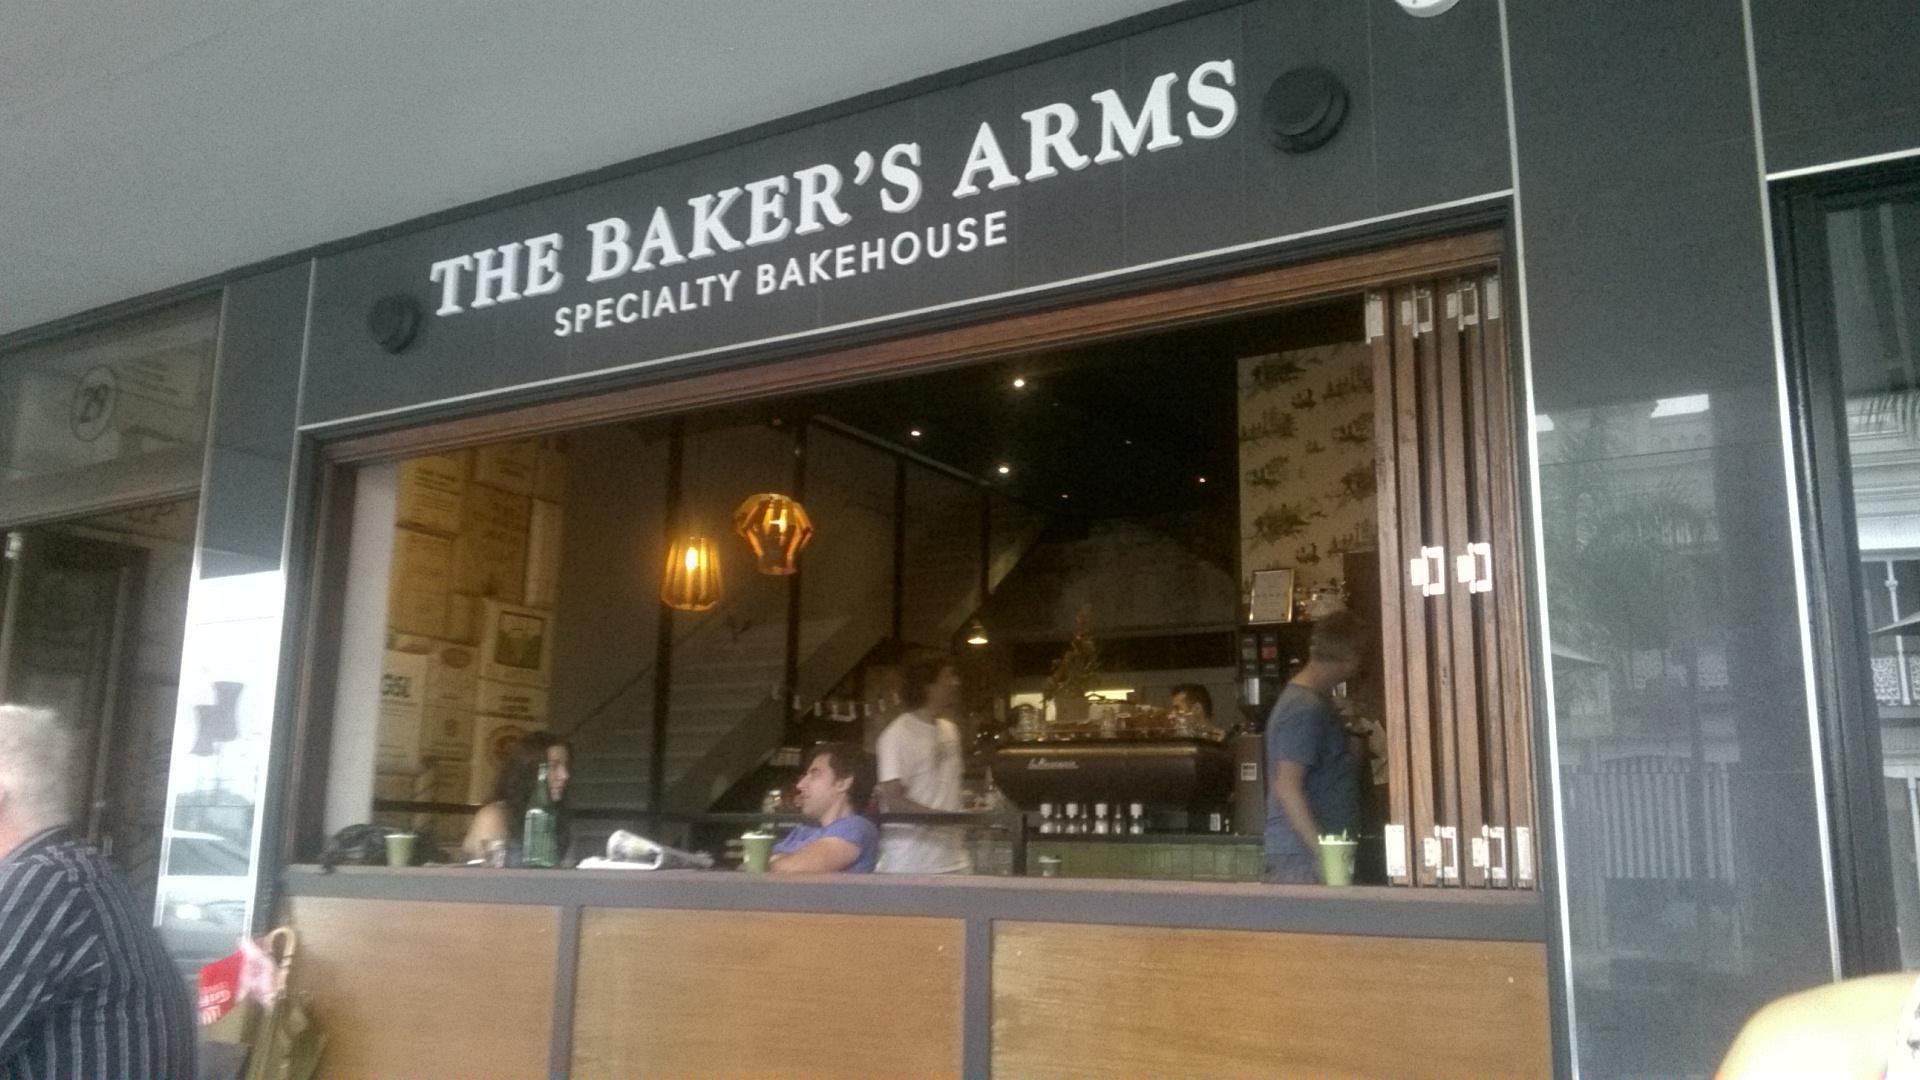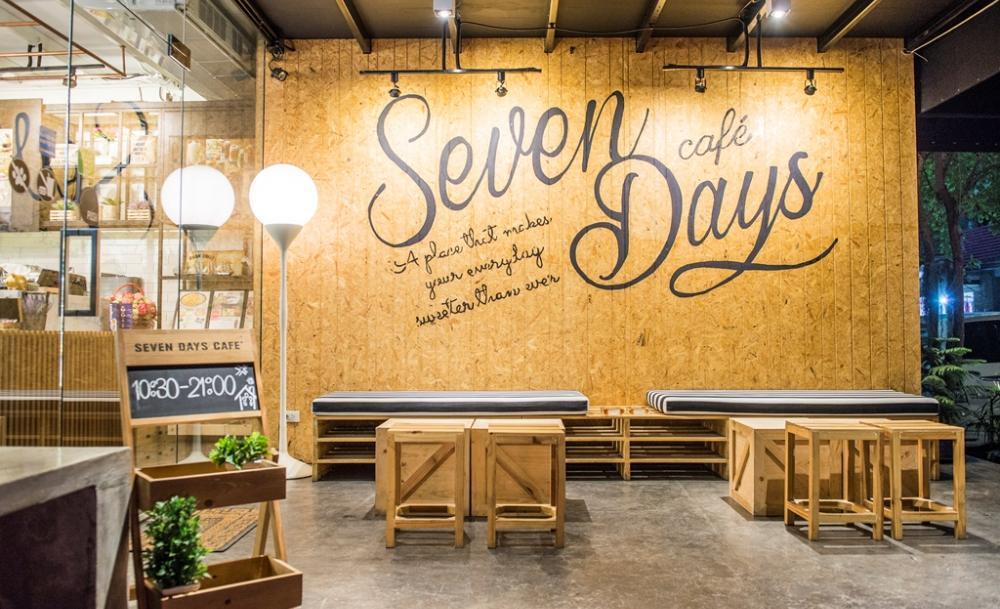The first image is the image on the left, the second image is the image on the right. Examine the images to the left and right. Is the description "There are awnings over the doors of both bakeries." accurate? Answer yes or no. No. 